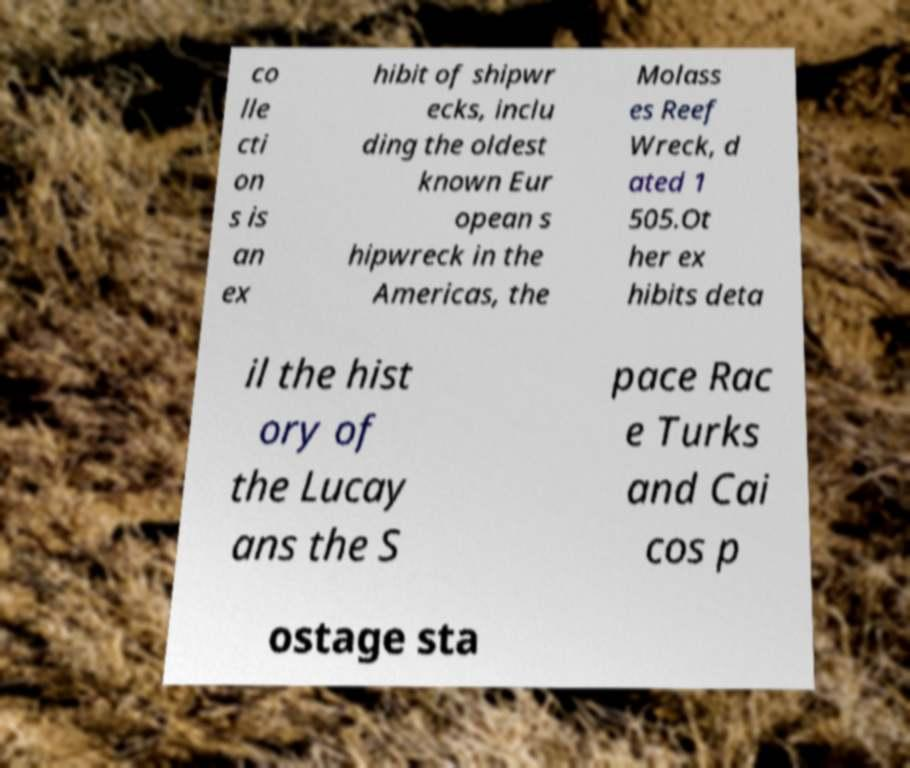Can you accurately transcribe the text from the provided image for me? co lle cti on s is an ex hibit of shipwr ecks, inclu ding the oldest known Eur opean s hipwreck in the Americas, the Molass es Reef Wreck, d ated 1 505.Ot her ex hibits deta il the hist ory of the Lucay ans the S pace Rac e Turks and Cai cos p ostage sta 